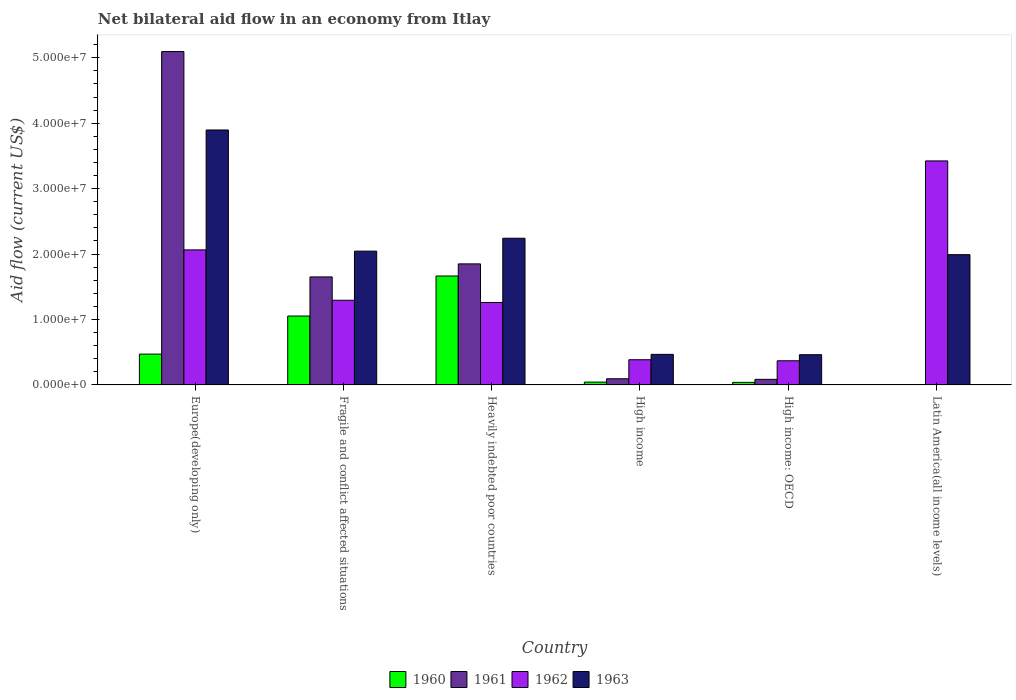How many different coloured bars are there?
Your answer should be very brief. 4. How many groups of bars are there?
Your response must be concise. 6. Are the number of bars on each tick of the X-axis equal?
Provide a short and direct response. No. How many bars are there on the 5th tick from the right?
Ensure brevity in your answer.  4. What is the label of the 1st group of bars from the left?
Your answer should be compact. Europe(developing only). Across all countries, what is the maximum net bilateral aid flow in 1962?
Provide a succinct answer. 3.42e+07. Across all countries, what is the minimum net bilateral aid flow in 1962?
Provide a succinct answer. 3.69e+06. In which country was the net bilateral aid flow in 1961 maximum?
Offer a very short reply. Europe(developing only). What is the total net bilateral aid flow in 1963 in the graph?
Your response must be concise. 1.11e+08. What is the difference between the net bilateral aid flow in 1960 in Europe(developing only) and that in Fragile and conflict affected situations?
Offer a very short reply. -5.82e+06. What is the difference between the net bilateral aid flow in 1963 in Latin America(all income levels) and the net bilateral aid flow in 1962 in Heavily indebted poor countries?
Keep it short and to the point. 7.31e+06. What is the average net bilateral aid flow in 1961 per country?
Give a very brief answer. 1.46e+07. What is the difference between the net bilateral aid flow of/in 1961 and net bilateral aid flow of/in 1960 in Fragile and conflict affected situations?
Provide a succinct answer. 5.98e+06. In how many countries, is the net bilateral aid flow in 1960 greater than 4000000 US$?
Make the answer very short. 3. What is the ratio of the net bilateral aid flow in 1961 in Fragile and conflict affected situations to that in Heavily indebted poor countries?
Provide a succinct answer. 0.89. Is the net bilateral aid flow in 1961 in Fragile and conflict affected situations less than that in High income: OECD?
Provide a short and direct response. No. Is the difference between the net bilateral aid flow in 1961 in Fragile and conflict affected situations and High income greater than the difference between the net bilateral aid flow in 1960 in Fragile and conflict affected situations and High income?
Your answer should be compact. Yes. What is the difference between the highest and the second highest net bilateral aid flow in 1962?
Your answer should be compact. 1.36e+07. What is the difference between the highest and the lowest net bilateral aid flow in 1962?
Your answer should be compact. 3.06e+07. In how many countries, is the net bilateral aid flow in 1961 greater than the average net bilateral aid flow in 1961 taken over all countries?
Your response must be concise. 3. Is it the case that in every country, the sum of the net bilateral aid flow in 1960 and net bilateral aid flow in 1962 is greater than the net bilateral aid flow in 1961?
Your answer should be compact. No. How many countries are there in the graph?
Offer a very short reply. 6. What is the difference between two consecutive major ticks on the Y-axis?
Provide a short and direct response. 1.00e+07. Does the graph contain grids?
Offer a terse response. No. Where does the legend appear in the graph?
Keep it short and to the point. Bottom center. How many legend labels are there?
Offer a terse response. 4. How are the legend labels stacked?
Give a very brief answer. Horizontal. What is the title of the graph?
Give a very brief answer. Net bilateral aid flow in an economy from Itlay. Does "1971" appear as one of the legend labels in the graph?
Keep it short and to the point. No. What is the Aid flow (current US$) of 1960 in Europe(developing only)?
Your answer should be very brief. 4.71e+06. What is the Aid flow (current US$) of 1961 in Europe(developing only)?
Your answer should be compact. 5.10e+07. What is the Aid flow (current US$) in 1962 in Europe(developing only)?
Provide a short and direct response. 2.06e+07. What is the Aid flow (current US$) of 1963 in Europe(developing only)?
Make the answer very short. 3.90e+07. What is the Aid flow (current US$) of 1960 in Fragile and conflict affected situations?
Provide a succinct answer. 1.05e+07. What is the Aid flow (current US$) of 1961 in Fragile and conflict affected situations?
Your response must be concise. 1.65e+07. What is the Aid flow (current US$) of 1962 in Fragile and conflict affected situations?
Your answer should be very brief. 1.29e+07. What is the Aid flow (current US$) in 1963 in Fragile and conflict affected situations?
Ensure brevity in your answer.  2.04e+07. What is the Aid flow (current US$) of 1960 in Heavily indebted poor countries?
Your response must be concise. 1.66e+07. What is the Aid flow (current US$) of 1961 in Heavily indebted poor countries?
Offer a terse response. 1.85e+07. What is the Aid flow (current US$) of 1962 in Heavily indebted poor countries?
Provide a short and direct response. 1.26e+07. What is the Aid flow (current US$) of 1963 in Heavily indebted poor countries?
Your answer should be very brief. 2.24e+07. What is the Aid flow (current US$) in 1961 in High income?
Provide a short and direct response. 9.40e+05. What is the Aid flow (current US$) in 1962 in High income?
Your response must be concise. 3.85e+06. What is the Aid flow (current US$) of 1963 in High income?
Make the answer very short. 4.67e+06. What is the Aid flow (current US$) of 1960 in High income: OECD?
Your answer should be very brief. 3.90e+05. What is the Aid flow (current US$) in 1961 in High income: OECD?
Provide a succinct answer. 8.50e+05. What is the Aid flow (current US$) of 1962 in High income: OECD?
Your response must be concise. 3.69e+06. What is the Aid flow (current US$) in 1963 in High income: OECD?
Offer a very short reply. 4.62e+06. What is the Aid flow (current US$) in 1961 in Latin America(all income levels)?
Ensure brevity in your answer.  0. What is the Aid flow (current US$) of 1962 in Latin America(all income levels)?
Provide a succinct answer. 3.42e+07. What is the Aid flow (current US$) in 1963 in Latin America(all income levels)?
Make the answer very short. 1.99e+07. Across all countries, what is the maximum Aid flow (current US$) of 1960?
Keep it short and to the point. 1.66e+07. Across all countries, what is the maximum Aid flow (current US$) of 1961?
Give a very brief answer. 5.10e+07. Across all countries, what is the maximum Aid flow (current US$) of 1962?
Your answer should be compact. 3.42e+07. Across all countries, what is the maximum Aid flow (current US$) of 1963?
Offer a very short reply. 3.90e+07. Across all countries, what is the minimum Aid flow (current US$) in 1960?
Keep it short and to the point. 0. Across all countries, what is the minimum Aid flow (current US$) in 1962?
Ensure brevity in your answer.  3.69e+06. Across all countries, what is the minimum Aid flow (current US$) of 1963?
Provide a succinct answer. 4.62e+06. What is the total Aid flow (current US$) of 1960 in the graph?
Give a very brief answer. 3.27e+07. What is the total Aid flow (current US$) of 1961 in the graph?
Your answer should be compact. 8.78e+07. What is the total Aid flow (current US$) of 1962 in the graph?
Offer a very short reply. 8.80e+07. What is the total Aid flow (current US$) in 1963 in the graph?
Your answer should be very brief. 1.11e+08. What is the difference between the Aid flow (current US$) in 1960 in Europe(developing only) and that in Fragile and conflict affected situations?
Ensure brevity in your answer.  -5.82e+06. What is the difference between the Aid flow (current US$) in 1961 in Europe(developing only) and that in Fragile and conflict affected situations?
Keep it short and to the point. 3.44e+07. What is the difference between the Aid flow (current US$) in 1962 in Europe(developing only) and that in Fragile and conflict affected situations?
Give a very brief answer. 7.70e+06. What is the difference between the Aid flow (current US$) of 1963 in Europe(developing only) and that in Fragile and conflict affected situations?
Make the answer very short. 1.85e+07. What is the difference between the Aid flow (current US$) of 1960 in Europe(developing only) and that in Heavily indebted poor countries?
Make the answer very short. -1.19e+07. What is the difference between the Aid flow (current US$) of 1961 in Europe(developing only) and that in Heavily indebted poor countries?
Your answer should be very brief. 3.25e+07. What is the difference between the Aid flow (current US$) of 1962 in Europe(developing only) and that in Heavily indebted poor countries?
Provide a short and direct response. 8.04e+06. What is the difference between the Aid flow (current US$) of 1963 in Europe(developing only) and that in Heavily indebted poor countries?
Offer a very short reply. 1.66e+07. What is the difference between the Aid flow (current US$) in 1960 in Europe(developing only) and that in High income?
Provide a short and direct response. 4.28e+06. What is the difference between the Aid flow (current US$) of 1961 in Europe(developing only) and that in High income?
Provide a short and direct response. 5.00e+07. What is the difference between the Aid flow (current US$) of 1962 in Europe(developing only) and that in High income?
Keep it short and to the point. 1.68e+07. What is the difference between the Aid flow (current US$) of 1963 in Europe(developing only) and that in High income?
Offer a very short reply. 3.43e+07. What is the difference between the Aid flow (current US$) in 1960 in Europe(developing only) and that in High income: OECD?
Make the answer very short. 4.32e+06. What is the difference between the Aid flow (current US$) of 1961 in Europe(developing only) and that in High income: OECD?
Provide a succinct answer. 5.01e+07. What is the difference between the Aid flow (current US$) of 1962 in Europe(developing only) and that in High income: OECD?
Your response must be concise. 1.70e+07. What is the difference between the Aid flow (current US$) in 1963 in Europe(developing only) and that in High income: OECD?
Your answer should be very brief. 3.44e+07. What is the difference between the Aid flow (current US$) in 1962 in Europe(developing only) and that in Latin America(all income levels)?
Give a very brief answer. -1.36e+07. What is the difference between the Aid flow (current US$) of 1963 in Europe(developing only) and that in Latin America(all income levels)?
Offer a very short reply. 1.91e+07. What is the difference between the Aid flow (current US$) of 1960 in Fragile and conflict affected situations and that in Heavily indebted poor countries?
Offer a very short reply. -6.12e+06. What is the difference between the Aid flow (current US$) of 1961 in Fragile and conflict affected situations and that in Heavily indebted poor countries?
Your answer should be very brief. -1.99e+06. What is the difference between the Aid flow (current US$) of 1963 in Fragile and conflict affected situations and that in Heavily indebted poor countries?
Offer a terse response. -1.97e+06. What is the difference between the Aid flow (current US$) of 1960 in Fragile and conflict affected situations and that in High income?
Keep it short and to the point. 1.01e+07. What is the difference between the Aid flow (current US$) in 1961 in Fragile and conflict affected situations and that in High income?
Keep it short and to the point. 1.56e+07. What is the difference between the Aid flow (current US$) in 1962 in Fragile and conflict affected situations and that in High income?
Provide a short and direct response. 9.09e+06. What is the difference between the Aid flow (current US$) of 1963 in Fragile and conflict affected situations and that in High income?
Your answer should be compact. 1.58e+07. What is the difference between the Aid flow (current US$) in 1960 in Fragile and conflict affected situations and that in High income: OECD?
Give a very brief answer. 1.01e+07. What is the difference between the Aid flow (current US$) in 1961 in Fragile and conflict affected situations and that in High income: OECD?
Your answer should be very brief. 1.57e+07. What is the difference between the Aid flow (current US$) in 1962 in Fragile and conflict affected situations and that in High income: OECD?
Offer a terse response. 9.25e+06. What is the difference between the Aid flow (current US$) of 1963 in Fragile and conflict affected situations and that in High income: OECD?
Your answer should be compact. 1.58e+07. What is the difference between the Aid flow (current US$) in 1962 in Fragile and conflict affected situations and that in Latin America(all income levels)?
Keep it short and to the point. -2.13e+07. What is the difference between the Aid flow (current US$) in 1963 in Fragile and conflict affected situations and that in Latin America(all income levels)?
Make the answer very short. 5.40e+05. What is the difference between the Aid flow (current US$) of 1960 in Heavily indebted poor countries and that in High income?
Give a very brief answer. 1.62e+07. What is the difference between the Aid flow (current US$) of 1961 in Heavily indebted poor countries and that in High income?
Offer a very short reply. 1.76e+07. What is the difference between the Aid flow (current US$) in 1962 in Heavily indebted poor countries and that in High income?
Your answer should be very brief. 8.75e+06. What is the difference between the Aid flow (current US$) of 1963 in Heavily indebted poor countries and that in High income?
Provide a succinct answer. 1.78e+07. What is the difference between the Aid flow (current US$) in 1960 in Heavily indebted poor countries and that in High income: OECD?
Give a very brief answer. 1.63e+07. What is the difference between the Aid flow (current US$) of 1961 in Heavily indebted poor countries and that in High income: OECD?
Ensure brevity in your answer.  1.76e+07. What is the difference between the Aid flow (current US$) in 1962 in Heavily indebted poor countries and that in High income: OECD?
Give a very brief answer. 8.91e+06. What is the difference between the Aid flow (current US$) in 1963 in Heavily indebted poor countries and that in High income: OECD?
Provide a short and direct response. 1.78e+07. What is the difference between the Aid flow (current US$) in 1962 in Heavily indebted poor countries and that in Latin America(all income levels)?
Ensure brevity in your answer.  -2.16e+07. What is the difference between the Aid flow (current US$) of 1963 in Heavily indebted poor countries and that in Latin America(all income levels)?
Offer a very short reply. 2.51e+06. What is the difference between the Aid flow (current US$) in 1960 in High income and that in High income: OECD?
Provide a short and direct response. 4.00e+04. What is the difference between the Aid flow (current US$) in 1961 in High income and that in High income: OECD?
Keep it short and to the point. 9.00e+04. What is the difference between the Aid flow (current US$) of 1963 in High income and that in High income: OECD?
Keep it short and to the point. 5.00e+04. What is the difference between the Aid flow (current US$) in 1962 in High income and that in Latin America(all income levels)?
Your response must be concise. -3.04e+07. What is the difference between the Aid flow (current US$) in 1963 in High income and that in Latin America(all income levels)?
Offer a terse response. -1.52e+07. What is the difference between the Aid flow (current US$) in 1962 in High income: OECD and that in Latin America(all income levels)?
Offer a terse response. -3.06e+07. What is the difference between the Aid flow (current US$) in 1963 in High income: OECD and that in Latin America(all income levels)?
Make the answer very short. -1.53e+07. What is the difference between the Aid flow (current US$) in 1960 in Europe(developing only) and the Aid flow (current US$) in 1961 in Fragile and conflict affected situations?
Keep it short and to the point. -1.18e+07. What is the difference between the Aid flow (current US$) of 1960 in Europe(developing only) and the Aid flow (current US$) of 1962 in Fragile and conflict affected situations?
Offer a terse response. -8.23e+06. What is the difference between the Aid flow (current US$) in 1960 in Europe(developing only) and the Aid flow (current US$) in 1963 in Fragile and conflict affected situations?
Provide a succinct answer. -1.57e+07. What is the difference between the Aid flow (current US$) in 1961 in Europe(developing only) and the Aid flow (current US$) in 1962 in Fragile and conflict affected situations?
Your answer should be compact. 3.80e+07. What is the difference between the Aid flow (current US$) of 1961 in Europe(developing only) and the Aid flow (current US$) of 1963 in Fragile and conflict affected situations?
Your response must be concise. 3.05e+07. What is the difference between the Aid flow (current US$) of 1962 in Europe(developing only) and the Aid flow (current US$) of 1963 in Fragile and conflict affected situations?
Keep it short and to the point. 1.90e+05. What is the difference between the Aid flow (current US$) in 1960 in Europe(developing only) and the Aid flow (current US$) in 1961 in Heavily indebted poor countries?
Keep it short and to the point. -1.38e+07. What is the difference between the Aid flow (current US$) of 1960 in Europe(developing only) and the Aid flow (current US$) of 1962 in Heavily indebted poor countries?
Offer a very short reply. -7.89e+06. What is the difference between the Aid flow (current US$) in 1960 in Europe(developing only) and the Aid flow (current US$) in 1963 in Heavily indebted poor countries?
Keep it short and to the point. -1.77e+07. What is the difference between the Aid flow (current US$) in 1961 in Europe(developing only) and the Aid flow (current US$) in 1962 in Heavily indebted poor countries?
Offer a very short reply. 3.84e+07. What is the difference between the Aid flow (current US$) of 1961 in Europe(developing only) and the Aid flow (current US$) of 1963 in Heavily indebted poor countries?
Your answer should be very brief. 2.85e+07. What is the difference between the Aid flow (current US$) of 1962 in Europe(developing only) and the Aid flow (current US$) of 1963 in Heavily indebted poor countries?
Give a very brief answer. -1.78e+06. What is the difference between the Aid flow (current US$) in 1960 in Europe(developing only) and the Aid flow (current US$) in 1961 in High income?
Make the answer very short. 3.77e+06. What is the difference between the Aid flow (current US$) of 1960 in Europe(developing only) and the Aid flow (current US$) of 1962 in High income?
Make the answer very short. 8.60e+05. What is the difference between the Aid flow (current US$) in 1961 in Europe(developing only) and the Aid flow (current US$) in 1962 in High income?
Offer a very short reply. 4.71e+07. What is the difference between the Aid flow (current US$) of 1961 in Europe(developing only) and the Aid flow (current US$) of 1963 in High income?
Ensure brevity in your answer.  4.63e+07. What is the difference between the Aid flow (current US$) of 1962 in Europe(developing only) and the Aid flow (current US$) of 1963 in High income?
Your response must be concise. 1.60e+07. What is the difference between the Aid flow (current US$) in 1960 in Europe(developing only) and the Aid flow (current US$) in 1961 in High income: OECD?
Offer a very short reply. 3.86e+06. What is the difference between the Aid flow (current US$) of 1960 in Europe(developing only) and the Aid flow (current US$) of 1962 in High income: OECD?
Your answer should be very brief. 1.02e+06. What is the difference between the Aid flow (current US$) in 1960 in Europe(developing only) and the Aid flow (current US$) in 1963 in High income: OECD?
Offer a very short reply. 9.00e+04. What is the difference between the Aid flow (current US$) in 1961 in Europe(developing only) and the Aid flow (current US$) in 1962 in High income: OECD?
Make the answer very short. 4.73e+07. What is the difference between the Aid flow (current US$) of 1961 in Europe(developing only) and the Aid flow (current US$) of 1963 in High income: OECD?
Offer a very short reply. 4.63e+07. What is the difference between the Aid flow (current US$) in 1962 in Europe(developing only) and the Aid flow (current US$) in 1963 in High income: OECD?
Keep it short and to the point. 1.60e+07. What is the difference between the Aid flow (current US$) of 1960 in Europe(developing only) and the Aid flow (current US$) of 1962 in Latin America(all income levels)?
Your answer should be very brief. -2.95e+07. What is the difference between the Aid flow (current US$) in 1960 in Europe(developing only) and the Aid flow (current US$) in 1963 in Latin America(all income levels)?
Offer a terse response. -1.52e+07. What is the difference between the Aid flow (current US$) of 1961 in Europe(developing only) and the Aid flow (current US$) of 1962 in Latin America(all income levels)?
Your answer should be compact. 1.67e+07. What is the difference between the Aid flow (current US$) of 1961 in Europe(developing only) and the Aid flow (current US$) of 1963 in Latin America(all income levels)?
Keep it short and to the point. 3.10e+07. What is the difference between the Aid flow (current US$) in 1962 in Europe(developing only) and the Aid flow (current US$) in 1963 in Latin America(all income levels)?
Your answer should be compact. 7.30e+05. What is the difference between the Aid flow (current US$) of 1960 in Fragile and conflict affected situations and the Aid flow (current US$) of 1961 in Heavily indebted poor countries?
Your answer should be very brief. -7.97e+06. What is the difference between the Aid flow (current US$) in 1960 in Fragile and conflict affected situations and the Aid flow (current US$) in 1962 in Heavily indebted poor countries?
Ensure brevity in your answer.  -2.07e+06. What is the difference between the Aid flow (current US$) in 1960 in Fragile and conflict affected situations and the Aid flow (current US$) in 1963 in Heavily indebted poor countries?
Your answer should be very brief. -1.19e+07. What is the difference between the Aid flow (current US$) in 1961 in Fragile and conflict affected situations and the Aid flow (current US$) in 1962 in Heavily indebted poor countries?
Your answer should be very brief. 3.91e+06. What is the difference between the Aid flow (current US$) of 1961 in Fragile and conflict affected situations and the Aid flow (current US$) of 1963 in Heavily indebted poor countries?
Ensure brevity in your answer.  -5.91e+06. What is the difference between the Aid flow (current US$) of 1962 in Fragile and conflict affected situations and the Aid flow (current US$) of 1963 in Heavily indebted poor countries?
Provide a succinct answer. -9.48e+06. What is the difference between the Aid flow (current US$) in 1960 in Fragile and conflict affected situations and the Aid flow (current US$) in 1961 in High income?
Your answer should be very brief. 9.59e+06. What is the difference between the Aid flow (current US$) of 1960 in Fragile and conflict affected situations and the Aid flow (current US$) of 1962 in High income?
Your answer should be very brief. 6.68e+06. What is the difference between the Aid flow (current US$) of 1960 in Fragile and conflict affected situations and the Aid flow (current US$) of 1963 in High income?
Offer a very short reply. 5.86e+06. What is the difference between the Aid flow (current US$) of 1961 in Fragile and conflict affected situations and the Aid flow (current US$) of 1962 in High income?
Make the answer very short. 1.27e+07. What is the difference between the Aid flow (current US$) in 1961 in Fragile and conflict affected situations and the Aid flow (current US$) in 1963 in High income?
Ensure brevity in your answer.  1.18e+07. What is the difference between the Aid flow (current US$) in 1962 in Fragile and conflict affected situations and the Aid flow (current US$) in 1963 in High income?
Offer a terse response. 8.27e+06. What is the difference between the Aid flow (current US$) in 1960 in Fragile and conflict affected situations and the Aid flow (current US$) in 1961 in High income: OECD?
Offer a very short reply. 9.68e+06. What is the difference between the Aid flow (current US$) in 1960 in Fragile and conflict affected situations and the Aid flow (current US$) in 1962 in High income: OECD?
Ensure brevity in your answer.  6.84e+06. What is the difference between the Aid flow (current US$) of 1960 in Fragile and conflict affected situations and the Aid flow (current US$) of 1963 in High income: OECD?
Provide a short and direct response. 5.91e+06. What is the difference between the Aid flow (current US$) in 1961 in Fragile and conflict affected situations and the Aid flow (current US$) in 1962 in High income: OECD?
Provide a succinct answer. 1.28e+07. What is the difference between the Aid flow (current US$) in 1961 in Fragile and conflict affected situations and the Aid flow (current US$) in 1963 in High income: OECD?
Your answer should be very brief. 1.19e+07. What is the difference between the Aid flow (current US$) of 1962 in Fragile and conflict affected situations and the Aid flow (current US$) of 1963 in High income: OECD?
Your response must be concise. 8.32e+06. What is the difference between the Aid flow (current US$) in 1960 in Fragile and conflict affected situations and the Aid flow (current US$) in 1962 in Latin America(all income levels)?
Provide a succinct answer. -2.37e+07. What is the difference between the Aid flow (current US$) of 1960 in Fragile and conflict affected situations and the Aid flow (current US$) of 1963 in Latin America(all income levels)?
Offer a terse response. -9.38e+06. What is the difference between the Aid flow (current US$) in 1961 in Fragile and conflict affected situations and the Aid flow (current US$) in 1962 in Latin America(all income levels)?
Offer a very short reply. -1.77e+07. What is the difference between the Aid flow (current US$) of 1961 in Fragile and conflict affected situations and the Aid flow (current US$) of 1963 in Latin America(all income levels)?
Your response must be concise. -3.40e+06. What is the difference between the Aid flow (current US$) of 1962 in Fragile and conflict affected situations and the Aid flow (current US$) of 1963 in Latin America(all income levels)?
Your response must be concise. -6.97e+06. What is the difference between the Aid flow (current US$) of 1960 in Heavily indebted poor countries and the Aid flow (current US$) of 1961 in High income?
Your answer should be compact. 1.57e+07. What is the difference between the Aid flow (current US$) of 1960 in Heavily indebted poor countries and the Aid flow (current US$) of 1962 in High income?
Offer a very short reply. 1.28e+07. What is the difference between the Aid flow (current US$) of 1960 in Heavily indebted poor countries and the Aid flow (current US$) of 1963 in High income?
Keep it short and to the point. 1.20e+07. What is the difference between the Aid flow (current US$) of 1961 in Heavily indebted poor countries and the Aid flow (current US$) of 1962 in High income?
Give a very brief answer. 1.46e+07. What is the difference between the Aid flow (current US$) in 1961 in Heavily indebted poor countries and the Aid flow (current US$) in 1963 in High income?
Your response must be concise. 1.38e+07. What is the difference between the Aid flow (current US$) of 1962 in Heavily indebted poor countries and the Aid flow (current US$) of 1963 in High income?
Give a very brief answer. 7.93e+06. What is the difference between the Aid flow (current US$) of 1960 in Heavily indebted poor countries and the Aid flow (current US$) of 1961 in High income: OECD?
Make the answer very short. 1.58e+07. What is the difference between the Aid flow (current US$) in 1960 in Heavily indebted poor countries and the Aid flow (current US$) in 1962 in High income: OECD?
Provide a short and direct response. 1.30e+07. What is the difference between the Aid flow (current US$) in 1960 in Heavily indebted poor countries and the Aid flow (current US$) in 1963 in High income: OECD?
Give a very brief answer. 1.20e+07. What is the difference between the Aid flow (current US$) of 1961 in Heavily indebted poor countries and the Aid flow (current US$) of 1962 in High income: OECD?
Keep it short and to the point. 1.48e+07. What is the difference between the Aid flow (current US$) in 1961 in Heavily indebted poor countries and the Aid flow (current US$) in 1963 in High income: OECD?
Offer a very short reply. 1.39e+07. What is the difference between the Aid flow (current US$) in 1962 in Heavily indebted poor countries and the Aid flow (current US$) in 1963 in High income: OECD?
Ensure brevity in your answer.  7.98e+06. What is the difference between the Aid flow (current US$) of 1960 in Heavily indebted poor countries and the Aid flow (current US$) of 1962 in Latin America(all income levels)?
Offer a terse response. -1.76e+07. What is the difference between the Aid flow (current US$) in 1960 in Heavily indebted poor countries and the Aid flow (current US$) in 1963 in Latin America(all income levels)?
Offer a terse response. -3.26e+06. What is the difference between the Aid flow (current US$) in 1961 in Heavily indebted poor countries and the Aid flow (current US$) in 1962 in Latin America(all income levels)?
Offer a very short reply. -1.57e+07. What is the difference between the Aid flow (current US$) in 1961 in Heavily indebted poor countries and the Aid flow (current US$) in 1963 in Latin America(all income levels)?
Keep it short and to the point. -1.41e+06. What is the difference between the Aid flow (current US$) of 1962 in Heavily indebted poor countries and the Aid flow (current US$) of 1963 in Latin America(all income levels)?
Offer a terse response. -7.31e+06. What is the difference between the Aid flow (current US$) in 1960 in High income and the Aid flow (current US$) in 1961 in High income: OECD?
Your answer should be very brief. -4.20e+05. What is the difference between the Aid flow (current US$) in 1960 in High income and the Aid flow (current US$) in 1962 in High income: OECD?
Your response must be concise. -3.26e+06. What is the difference between the Aid flow (current US$) of 1960 in High income and the Aid flow (current US$) of 1963 in High income: OECD?
Ensure brevity in your answer.  -4.19e+06. What is the difference between the Aid flow (current US$) of 1961 in High income and the Aid flow (current US$) of 1962 in High income: OECD?
Keep it short and to the point. -2.75e+06. What is the difference between the Aid flow (current US$) of 1961 in High income and the Aid flow (current US$) of 1963 in High income: OECD?
Offer a very short reply. -3.68e+06. What is the difference between the Aid flow (current US$) in 1962 in High income and the Aid flow (current US$) in 1963 in High income: OECD?
Your answer should be very brief. -7.70e+05. What is the difference between the Aid flow (current US$) of 1960 in High income and the Aid flow (current US$) of 1962 in Latin America(all income levels)?
Offer a terse response. -3.38e+07. What is the difference between the Aid flow (current US$) in 1960 in High income and the Aid flow (current US$) in 1963 in Latin America(all income levels)?
Give a very brief answer. -1.95e+07. What is the difference between the Aid flow (current US$) of 1961 in High income and the Aid flow (current US$) of 1962 in Latin America(all income levels)?
Your answer should be very brief. -3.33e+07. What is the difference between the Aid flow (current US$) of 1961 in High income and the Aid flow (current US$) of 1963 in Latin America(all income levels)?
Your response must be concise. -1.90e+07. What is the difference between the Aid flow (current US$) of 1962 in High income and the Aid flow (current US$) of 1963 in Latin America(all income levels)?
Offer a terse response. -1.61e+07. What is the difference between the Aid flow (current US$) in 1960 in High income: OECD and the Aid flow (current US$) in 1962 in Latin America(all income levels)?
Offer a terse response. -3.38e+07. What is the difference between the Aid flow (current US$) in 1960 in High income: OECD and the Aid flow (current US$) in 1963 in Latin America(all income levels)?
Keep it short and to the point. -1.95e+07. What is the difference between the Aid flow (current US$) of 1961 in High income: OECD and the Aid flow (current US$) of 1962 in Latin America(all income levels)?
Make the answer very short. -3.34e+07. What is the difference between the Aid flow (current US$) in 1961 in High income: OECD and the Aid flow (current US$) in 1963 in Latin America(all income levels)?
Provide a short and direct response. -1.91e+07. What is the difference between the Aid flow (current US$) of 1962 in High income: OECD and the Aid flow (current US$) of 1963 in Latin America(all income levels)?
Provide a short and direct response. -1.62e+07. What is the average Aid flow (current US$) of 1960 per country?
Give a very brief answer. 5.45e+06. What is the average Aid flow (current US$) in 1961 per country?
Your response must be concise. 1.46e+07. What is the average Aid flow (current US$) of 1962 per country?
Give a very brief answer. 1.47e+07. What is the average Aid flow (current US$) in 1963 per country?
Ensure brevity in your answer.  1.85e+07. What is the difference between the Aid flow (current US$) of 1960 and Aid flow (current US$) of 1961 in Europe(developing only)?
Your answer should be compact. -4.62e+07. What is the difference between the Aid flow (current US$) of 1960 and Aid flow (current US$) of 1962 in Europe(developing only)?
Your response must be concise. -1.59e+07. What is the difference between the Aid flow (current US$) in 1960 and Aid flow (current US$) in 1963 in Europe(developing only)?
Give a very brief answer. -3.43e+07. What is the difference between the Aid flow (current US$) in 1961 and Aid flow (current US$) in 1962 in Europe(developing only)?
Keep it short and to the point. 3.03e+07. What is the difference between the Aid flow (current US$) in 1961 and Aid flow (current US$) in 1963 in Europe(developing only)?
Ensure brevity in your answer.  1.20e+07. What is the difference between the Aid flow (current US$) in 1962 and Aid flow (current US$) in 1963 in Europe(developing only)?
Your answer should be very brief. -1.83e+07. What is the difference between the Aid flow (current US$) of 1960 and Aid flow (current US$) of 1961 in Fragile and conflict affected situations?
Your answer should be very brief. -5.98e+06. What is the difference between the Aid flow (current US$) in 1960 and Aid flow (current US$) in 1962 in Fragile and conflict affected situations?
Give a very brief answer. -2.41e+06. What is the difference between the Aid flow (current US$) of 1960 and Aid flow (current US$) of 1963 in Fragile and conflict affected situations?
Your answer should be compact. -9.92e+06. What is the difference between the Aid flow (current US$) in 1961 and Aid flow (current US$) in 1962 in Fragile and conflict affected situations?
Give a very brief answer. 3.57e+06. What is the difference between the Aid flow (current US$) of 1961 and Aid flow (current US$) of 1963 in Fragile and conflict affected situations?
Your answer should be compact. -3.94e+06. What is the difference between the Aid flow (current US$) of 1962 and Aid flow (current US$) of 1963 in Fragile and conflict affected situations?
Offer a terse response. -7.51e+06. What is the difference between the Aid flow (current US$) of 1960 and Aid flow (current US$) of 1961 in Heavily indebted poor countries?
Your response must be concise. -1.85e+06. What is the difference between the Aid flow (current US$) in 1960 and Aid flow (current US$) in 1962 in Heavily indebted poor countries?
Keep it short and to the point. 4.05e+06. What is the difference between the Aid flow (current US$) in 1960 and Aid flow (current US$) in 1963 in Heavily indebted poor countries?
Provide a succinct answer. -5.77e+06. What is the difference between the Aid flow (current US$) of 1961 and Aid flow (current US$) of 1962 in Heavily indebted poor countries?
Provide a short and direct response. 5.90e+06. What is the difference between the Aid flow (current US$) of 1961 and Aid flow (current US$) of 1963 in Heavily indebted poor countries?
Make the answer very short. -3.92e+06. What is the difference between the Aid flow (current US$) in 1962 and Aid flow (current US$) in 1963 in Heavily indebted poor countries?
Keep it short and to the point. -9.82e+06. What is the difference between the Aid flow (current US$) in 1960 and Aid flow (current US$) in 1961 in High income?
Provide a short and direct response. -5.10e+05. What is the difference between the Aid flow (current US$) in 1960 and Aid flow (current US$) in 1962 in High income?
Your answer should be very brief. -3.42e+06. What is the difference between the Aid flow (current US$) in 1960 and Aid flow (current US$) in 1963 in High income?
Your response must be concise. -4.24e+06. What is the difference between the Aid flow (current US$) in 1961 and Aid flow (current US$) in 1962 in High income?
Keep it short and to the point. -2.91e+06. What is the difference between the Aid flow (current US$) of 1961 and Aid flow (current US$) of 1963 in High income?
Give a very brief answer. -3.73e+06. What is the difference between the Aid flow (current US$) of 1962 and Aid flow (current US$) of 1963 in High income?
Offer a very short reply. -8.20e+05. What is the difference between the Aid flow (current US$) of 1960 and Aid flow (current US$) of 1961 in High income: OECD?
Your answer should be compact. -4.60e+05. What is the difference between the Aid flow (current US$) of 1960 and Aid flow (current US$) of 1962 in High income: OECD?
Your response must be concise. -3.30e+06. What is the difference between the Aid flow (current US$) of 1960 and Aid flow (current US$) of 1963 in High income: OECD?
Your response must be concise. -4.23e+06. What is the difference between the Aid flow (current US$) in 1961 and Aid flow (current US$) in 1962 in High income: OECD?
Keep it short and to the point. -2.84e+06. What is the difference between the Aid flow (current US$) of 1961 and Aid flow (current US$) of 1963 in High income: OECD?
Provide a succinct answer. -3.77e+06. What is the difference between the Aid flow (current US$) of 1962 and Aid flow (current US$) of 1963 in High income: OECD?
Provide a succinct answer. -9.30e+05. What is the difference between the Aid flow (current US$) in 1962 and Aid flow (current US$) in 1963 in Latin America(all income levels)?
Keep it short and to the point. 1.43e+07. What is the ratio of the Aid flow (current US$) of 1960 in Europe(developing only) to that in Fragile and conflict affected situations?
Offer a very short reply. 0.45. What is the ratio of the Aid flow (current US$) in 1961 in Europe(developing only) to that in Fragile and conflict affected situations?
Ensure brevity in your answer.  3.09. What is the ratio of the Aid flow (current US$) of 1962 in Europe(developing only) to that in Fragile and conflict affected situations?
Provide a succinct answer. 1.6. What is the ratio of the Aid flow (current US$) in 1963 in Europe(developing only) to that in Fragile and conflict affected situations?
Ensure brevity in your answer.  1.91. What is the ratio of the Aid flow (current US$) of 1960 in Europe(developing only) to that in Heavily indebted poor countries?
Your response must be concise. 0.28. What is the ratio of the Aid flow (current US$) in 1961 in Europe(developing only) to that in Heavily indebted poor countries?
Keep it short and to the point. 2.75. What is the ratio of the Aid flow (current US$) in 1962 in Europe(developing only) to that in Heavily indebted poor countries?
Ensure brevity in your answer.  1.64. What is the ratio of the Aid flow (current US$) in 1963 in Europe(developing only) to that in Heavily indebted poor countries?
Provide a succinct answer. 1.74. What is the ratio of the Aid flow (current US$) in 1960 in Europe(developing only) to that in High income?
Keep it short and to the point. 10.95. What is the ratio of the Aid flow (current US$) of 1961 in Europe(developing only) to that in High income?
Offer a very short reply. 54.21. What is the ratio of the Aid flow (current US$) in 1962 in Europe(developing only) to that in High income?
Keep it short and to the point. 5.36. What is the ratio of the Aid flow (current US$) of 1963 in Europe(developing only) to that in High income?
Ensure brevity in your answer.  8.34. What is the ratio of the Aid flow (current US$) of 1960 in Europe(developing only) to that in High income: OECD?
Make the answer very short. 12.08. What is the ratio of the Aid flow (current US$) in 1961 in Europe(developing only) to that in High income: OECD?
Your answer should be compact. 59.95. What is the ratio of the Aid flow (current US$) in 1962 in Europe(developing only) to that in High income: OECD?
Make the answer very short. 5.59. What is the ratio of the Aid flow (current US$) in 1963 in Europe(developing only) to that in High income: OECD?
Offer a terse response. 8.44. What is the ratio of the Aid flow (current US$) of 1962 in Europe(developing only) to that in Latin America(all income levels)?
Your response must be concise. 0.6. What is the ratio of the Aid flow (current US$) of 1963 in Europe(developing only) to that in Latin America(all income levels)?
Give a very brief answer. 1.96. What is the ratio of the Aid flow (current US$) of 1960 in Fragile and conflict affected situations to that in Heavily indebted poor countries?
Your response must be concise. 0.63. What is the ratio of the Aid flow (current US$) of 1961 in Fragile and conflict affected situations to that in Heavily indebted poor countries?
Offer a very short reply. 0.89. What is the ratio of the Aid flow (current US$) in 1963 in Fragile and conflict affected situations to that in Heavily indebted poor countries?
Provide a short and direct response. 0.91. What is the ratio of the Aid flow (current US$) of 1960 in Fragile and conflict affected situations to that in High income?
Keep it short and to the point. 24.49. What is the ratio of the Aid flow (current US$) in 1961 in Fragile and conflict affected situations to that in High income?
Make the answer very short. 17.56. What is the ratio of the Aid flow (current US$) of 1962 in Fragile and conflict affected situations to that in High income?
Make the answer very short. 3.36. What is the ratio of the Aid flow (current US$) of 1963 in Fragile and conflict affected situations to that in High income?
Ensure brevity in your answer.  4.38. What is the ratio of the Aid flow (current US$) of 1961 in Fragile and conflict affected situations to that in High income: OECD?
Keep it short and to the point. 19.42. What is the ratio of the Aid flow (current US$) of 1962 in Fragile and conflict affected situations to that in High income: OECD?
Offer a very short reply. 3.51. What is the ratio of the Aid flow (current US$) of 1963 in Fragile and conflict affected situations to that in High income: OECD?
Offer a very short reply. 4.43. What is the ratio of the Aid flow (current US$) of 1962 in Fragile and conflict affected situations to that in Latin America(all income levels)?
Make the answer very short. 0.38. What is the ratio of the Aid flow (current US$) in 1963 in Fragile and conflict affected situations to that in Latin America(all income levels)?
Your answer should be very brief. 1.03. What is the ratio of the Aid flow (current US$) of 1960 in Heavily indebted poor countries to that in High income?
Give a very brief answer. 38.72. What is the ratio of the Aid flow (current US$) of 1961 in Heavily indebted poor countries to that in High income?
Offer a terse response. 19.68. What is the ratio of the Aid flow (current US$) of 1962 in Heavily indebted poor countries to that in High income?
Keep it short and to the point. 3.27. What is the ratio of the Aid flow (current US$) of 1963 in Heavily indebted poor countries to that in High income?
Offer a terse response. 4.8. What is the ratio of the Aid flow (current US$) of 1960 in Heavily indebted poor countries to that in High income: OECD?
Make the answer very short. 42.69. What is the ratio of the Aid flow (current US$) of 1961 in Heavily indebted poor countries to that in High income: OECD?
Provide a short and direct response. 21.76. What is the ratio of the Aid flow (current US$) in 1962 in Heavily indebted poor countries to that in High income: OECD?
Your response must be concise. 3.41. What is the ratio of the Aid flow (current US$) of 1963 in Heavily indebted poor countries to that in High income: OECD?
Give a very brief answer. 4.85. What is the ratio of the Aid flow (current US$) in 1962 in Heavily indebted poor countries to that in Latin America(all income levels)?
Make the answer very short. 0.37. What is the ratio of the Aid flow (current US$) of 1963 in Heavily indebted poor countries to that in Latin America(all income levels)?
Your answer should be very brief. 1.13. What is the ratio of the Aid flow (current US$) of 1960 in High income to that in High income: OECD?
Your answer should be very brief. 1.1. What is the ratio of the Aid flow (current US$) of 1961 in High income to that in High income: OECD?
Ensure brevity in your answer.  1.11. What is the ratio of the Aid flow (current US$) in 1962 in High income to that in High income: OECD?
Make the answer very short. 1.04. What is the ratio of the Aid flow (current US$) in 1963 in High income to that in High income: OECD?
Ensure brevity in your answer.  1.01. What is the ratio of the Aid flow (current US$) of 1962 in High income to that in Latin America(all income levels)?
Keep it short and to the point. 0.11. What is the ratio of the Aid flow (current US$) of 1963 in High income to that in Latin America(all income levels)?
Offer a terse response. 0.23. What is the ratio of the Aid flow (current US$) of 1962 in High income: OECD to that in Latin America(all income levels)?
Ensure brevity in your answer.  0.11. What is the ratio of the Aid flow (current US$) of 1963 in High income: OECD to that in Latin America(all income levels)?
Keep it short and to the point. 0.23. What is the difference between the highest and the second highest Aid flow (current US$) in 1960?
Ensure brevity in your answer.  6.12e+06. What is the difference between the highest and the second highest Aid flow (current US$) in 1961?
Provide a succinct answer. 3.25e+07. What is the difference between the highest and the second highest Aid flow (current US$) in 1962?
Make the answer very short. 1.36e+07. What is the difference between the highest and the second highest Aid flow (current US$) in 1963?
Your response must be concise. 1.66e+07. What is the difference between the highest and the lowest Aid flow (current US$) of 1960?
Your response must be concise. 1.66e+07. What is the difference between the highest and the lowest Aid flow (current US$) of 1961?
Keep it short and to the point. 5.10e+07. What is the difference between the highest and the lowest Aid flow (current US$) of 1962?
Your response must be concise. 3.06e+07. What is the difference between the highest and the lowest Aid flow (current US$) of 1963?
Your answer should be very brief. 3.44e+07. 